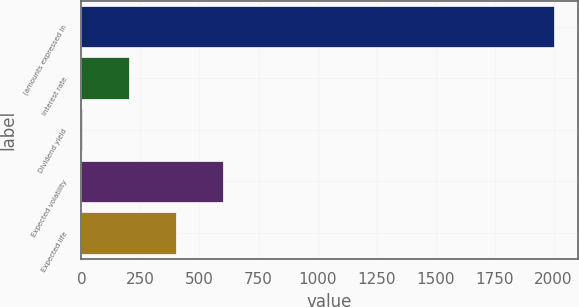Convert chart. <chart><loc_0><loc_0><loc_500><loc_500><bar_chart><fcel>(amounts expressed in<fcel>Interest rate<fcel>Dividend yield<fcel>Expected volatility<fcel>Expected life<nl><fcel>2002<fcel>200.59<fcel>0.43<fcel>600.91<fcel>400.75<nl></chart> 